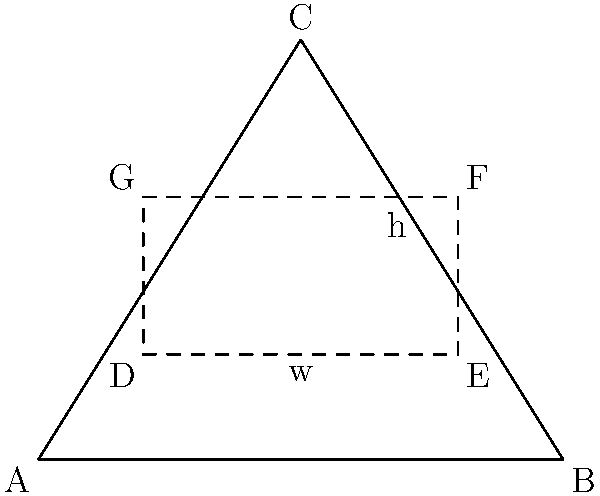A triangular plot of land ABC is available for constructing a rectangular building. The base of the triangle (AB) is 10 units long, and its height (from C to AB) is 8 units. What are the dimensions of the rectangular building that would maximize its area within this triangular plot? To solve this problem, we need to follow these steps:

1) Let the width of the rectangle be $w$ and its height be $h$.

2) The area of the rectangle is $A = wh$.

3) From the properties of similar triangles, we can establish that:

   $\frac{w}{10} = \frac{8-h}{8}$

4) Solving for $h$:
   
   $h = 8 - \frac{8w}{10} = 8 - 0.8w$

5) Now, we can express the area in terms of $w$:

   $A = w(8 - 0.8w) = 8w - 0.8w^2$

6) To find the maximum area, we differentiate $A$ with respect to $w$ and set it to zero:

   $\frac{dA}{dw} = 8 - 1.6w = 0$

7) Solving this:

   $8 - 1.6w = 0$
   $1.6w = 8$
   $w = 5$

8) We can confirm this is a maximum by checking the second derivative is negative.

9) Substituting $w = 5$ back into the equation for $h$:

   $h = 8 - 0.8(5) = 4$

Therefore, the optimal dimensions are width = 5 units and height = 4 units.

This solution maximizes land use efficiency, which is crucial for economic development in land-constrained areas.
Answer: Width = 5 units, Height = 4 units 